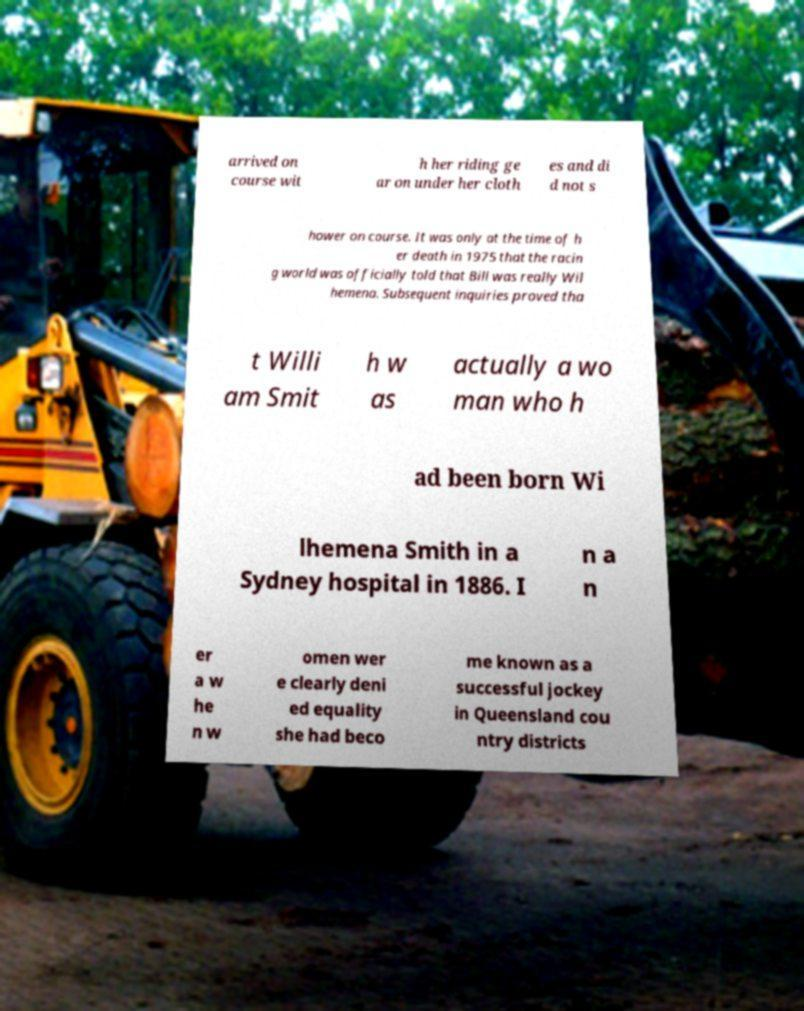Could you assist in decoding the text presented in this image and type it out clearly? arrived on course wit h her riding ge ar on under her cloth es and di d not s hower on course. It was only at the time of h er death in 1975 that the racin g world was officially told that Bill was really Wil hemena. Subsequent inquiries proved tha t Willi am Smit h w as actually a wo man who h ad been born Wi lhemena Smith in a Sydney hospital in 1886. I n a n er a w he n w omen wer e clearly deni ed equality she had beco me known as a successful jockey in Queensland cou ntry districts 